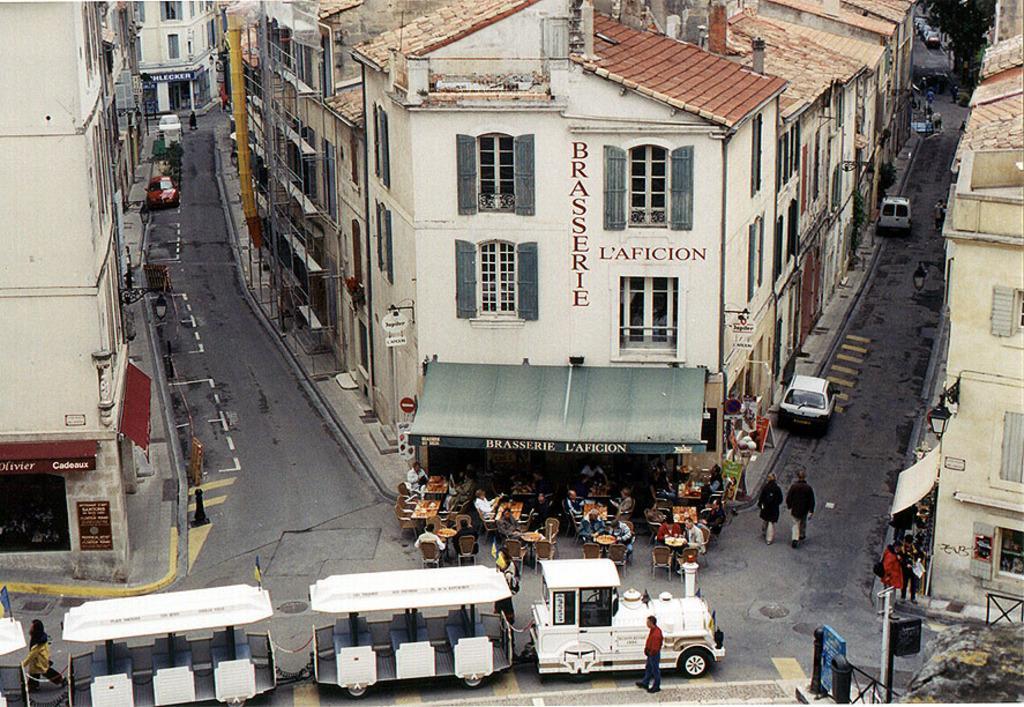Could you give a brief overview of what you see in this image? In this image there are buildings, cars and at the center people are sitting on the chairs and in front of them there is a table. At front there is a train and beside the train a person is standing. 